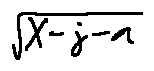<formula> <loc_0><loc_0><loc_500><loc_500>\sqrt { X - j - a }</formula> 